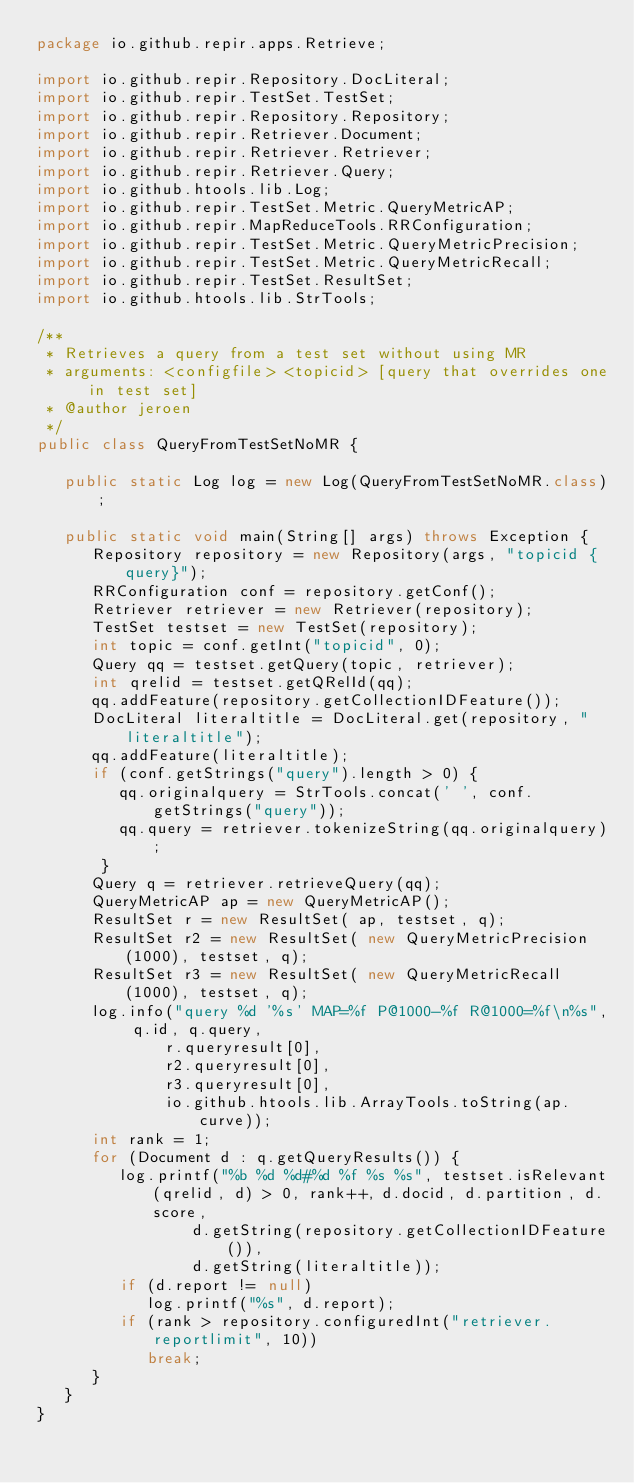<code> <loc_0><loc_0><loc_500><loc_500><_Java_>package io.github.repir.apps.Retrieve;

import io.github.repir.Repository.DocLiteral;
import io.github.repir.TestSet.TestSet;
import io.github.repir.Repository.Repository;
import io.github.repir.Retriever.Document;
import io.github.repir.Retriever.Retriever;
import io.github.repir.Retriever.Query;
import io.github.htools.lib.Log;
import io.github.repir.TestSet.Metric.QueryMetricAP;
import io.github.repir.MapReduceTools.RRConfiguration;
import io.github.repir.TestSet.Metric.QueryMetricPrecision;
import io.github.repir.TestSet.Metric.QueryMetricRecall;
import io.github.repir.TestSet.ResultSet;
import io.github.htools.lib.StrTools;

/**
 * Retrieves a query from a test set without using MR
 * arguments: <configfile> <topicid> [query that overrides one in test set]
 * @author jeroen
 */
public class QueryFromTestSetNoMR {

   public static Log log = new Log(QueryFromTestSetNoMR.class);

   public static void main(String[] args) throws Exception {
      Repository repository = new Repository(args, "topicid {query}");
      RRConfiguration conf = repository.getConf();
      Retriever retriever = new Retriever(repository);
      TestSet testset = new TestSet(repository);
      int topic = conf.getInt("topicid", 0);
      Query qq = testset.getQuery(topic, retriever);
      int qrelid = testset.getQRelId(qq);
      qq.addFeature(repository.getCollectionIDFeature());
      DocLiteral literaltitle = DocLiteral.get(repository, "literaltitle");
      qq.addFeature(literaltitle);
      if (conf.getStrings("query").length > 0) {
         qq.originalquery = StrTools.concat(' ', conf.getStrings("query"));
         qq.query = retriever.tokenizeString(qq.originalquery);
       }
      Query q = retriever.retrieveQuery(qq);
      QueryMetricAP ap = new QueryMetricAP();
      ResultSet r = new ResultSet( ap, testset, q);
      ResultSet r2 = new ResultSet( new QueryMetricPrecision(1000), testset, q);
      ResultSet r3 = new ResultSet( new QueryMetricRecall(1000), testset, q);
      log.info("query %d '%s' MAP=%f P@1000-%f R@1000=%f\n%s", q.id, q.query, 
              r.queryresult[0], 
              r2.queryresult[0], 
              r3.queryresult[0], 
              io.github.htools.lib.ArrayTools.toString(ap.curve));
      int rank = 1;
      for (Document d : q.getQueryResults()) {
         log.printf("%b %d %d#%d %f %s %s", testset.isRelevant(qrelid, d) > 0, rank++, d.docid, d.partition, d.score,
                 d.getString(repository.getCollectionIDFeature()), 
                 d.getString(literaltitle));
         if (d.report != null)
            log.printf("%s", d.report);
         if (rank > repository.configuredInt("retriever.reportlimit", 10))
            break;
      }
   }
}
</code> 